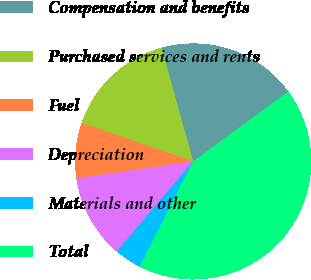Convert chart. <chart><loc_0><loc_0><loc_500><loc_500><pie_chart><fcel>Compensation and benefits<fcel>Purchased services and rents<fcel>Fuel<fcel>Depreciation<fcel>Materials and other<fcel>Total<nl><fcel>19.26%<fcel>15.37%<fcel>7.6%<fcel>11.49%<fcel>3.72%<fcel>42.56%<nl></chart> 